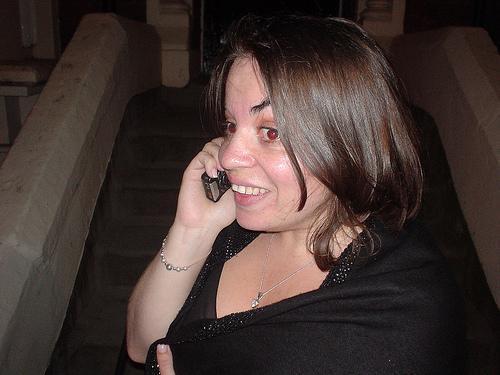How many people are in this photo?
Give a very brief answer. 1. 